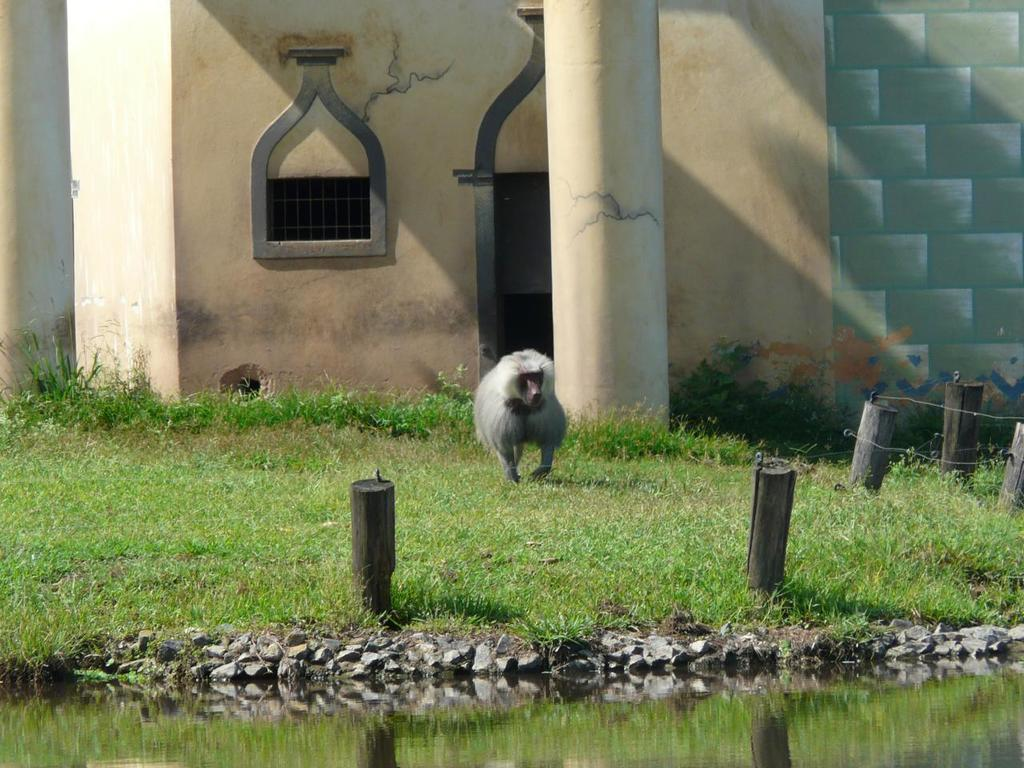What animal can be seen in the picture? There is a monkey in the picture. What type of surface is the monkey standing on? There is grass on the floor in the picture. What body of water is present in the picture? There is a small pond in the picture. What can be seen in the distance in the picture? There is a building and pillars in the background of the picture. What type of paper is the monkey holding in the picture? There is no paper present in the image; the monkey is not holding anything. 